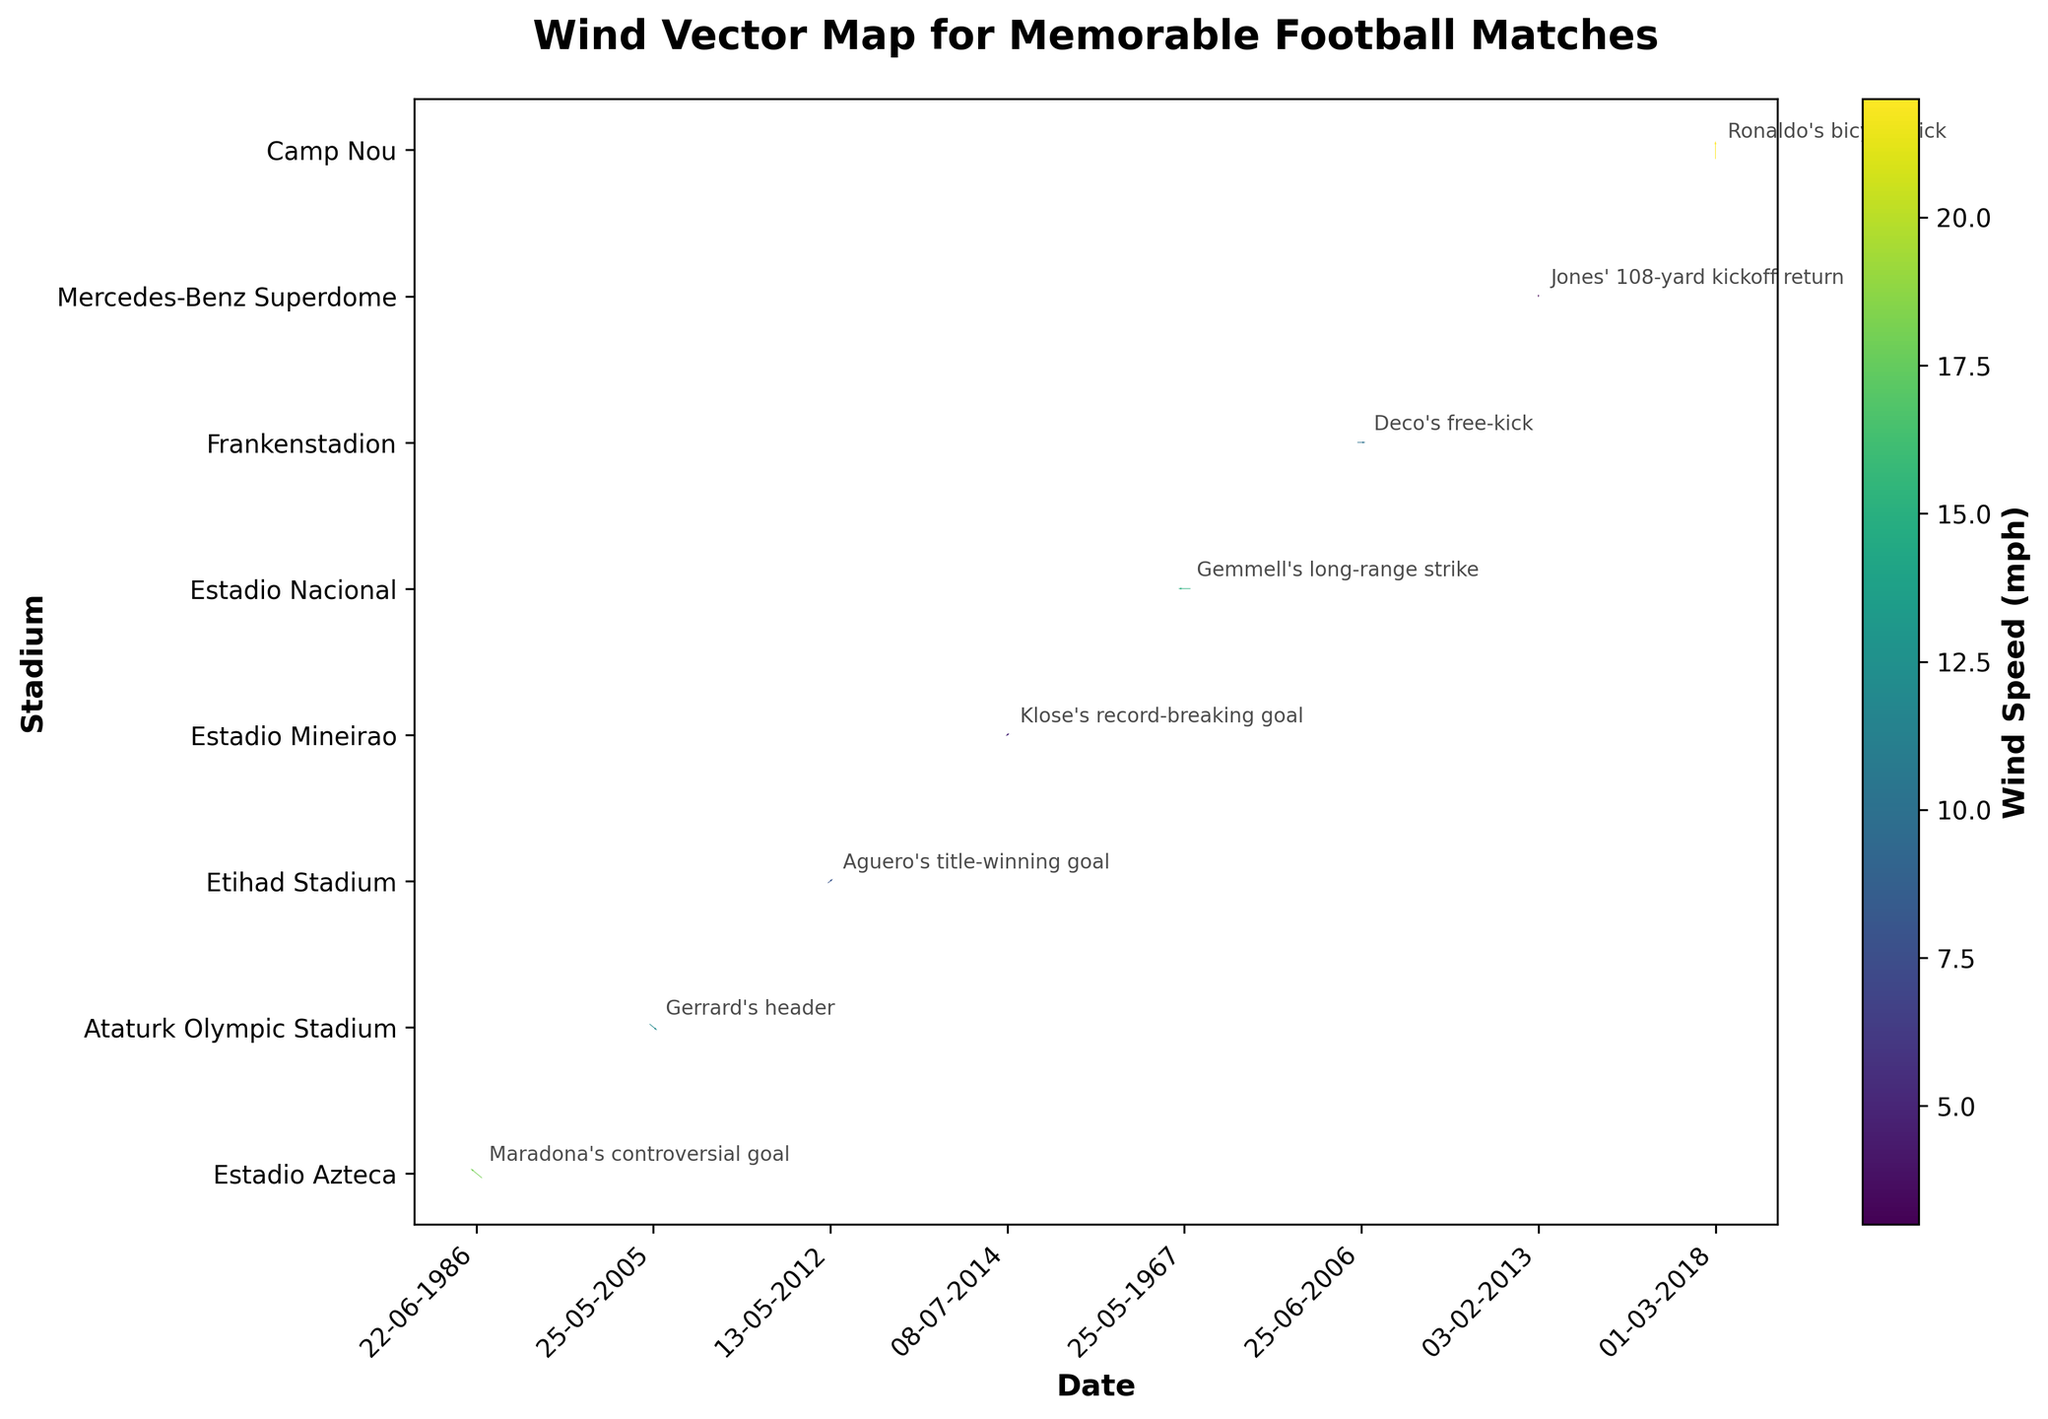What is the title of the figure? The title of the figure is placed at the top of the chart. Reading it reveals the main subject of the visualization.
Answer: Wind Vector Map for Memorable Football Matches What is the direction and speed of the wind during "The Miracle of Istanbul"? Refer to the "Memorable Play" annotation for "The Miracle of Istanbul" and then check the direction and speed data for the corresponding point.
Answer: NW, 12 mph Which match experienced the highest wind speed and what was the memorable play during that match? Locate the vectors (arrows) on the map and identify the one with the highest magnitude. Cross-reference it with the annotations to find the memorable play.
Answer: "The Snow Clasico" with Ronaldo's bicycle kick Compare the wind speed during "Aguerooooo" and "The Super Bowl Blackout." Which match had higher wind speed? Check the wind speed annotations for both matches. Compare 8 mph for "Aguerooooo" and 3 mph for "The Super Bowl Blackout."
Answer: "Aguerooooo" with 8 mph What wind direction was present during Maradona's controversial goal in the "Hand of God" match? Refer to the annotation for "Hand of God" and look at the corresponding direction data.
Answer: SE Which match had the wind coming from the east and what was the wind speed? Look for a vector pointing to the E direction and find the corresponding match annotation.
Answer: "The Lisbon Lions" with 15 mph How many matches experienced a wind speed greater than 10 mph? Count the number of vectors with annotated wind speeds greater than 10 mph.
Answer: 5 matches What wind speed and direction were present during Klose's record-breaking goal in the "Brazil 1-7 Germany" match? Find the annotation for "Brazil 1-7 Germany" and check the corresponding direction and speed data.
Answer: NE, 5 mph Which stadium experienced the highest wind speed, and during which match? Identify the vector with the highest magnitude and check its corresponding stadium annotation.
Answer: Camp Nou during "The Snow Clasico" What is the average wind speed across all memorable matches? Sum the wind speeds of all matches and divide by the total number of matches. Calculation: (18 + 12 + 8 + 5 + 15 + 10 + 3 + 22) / 8 = 11.625
Answer: 11.625 mph 